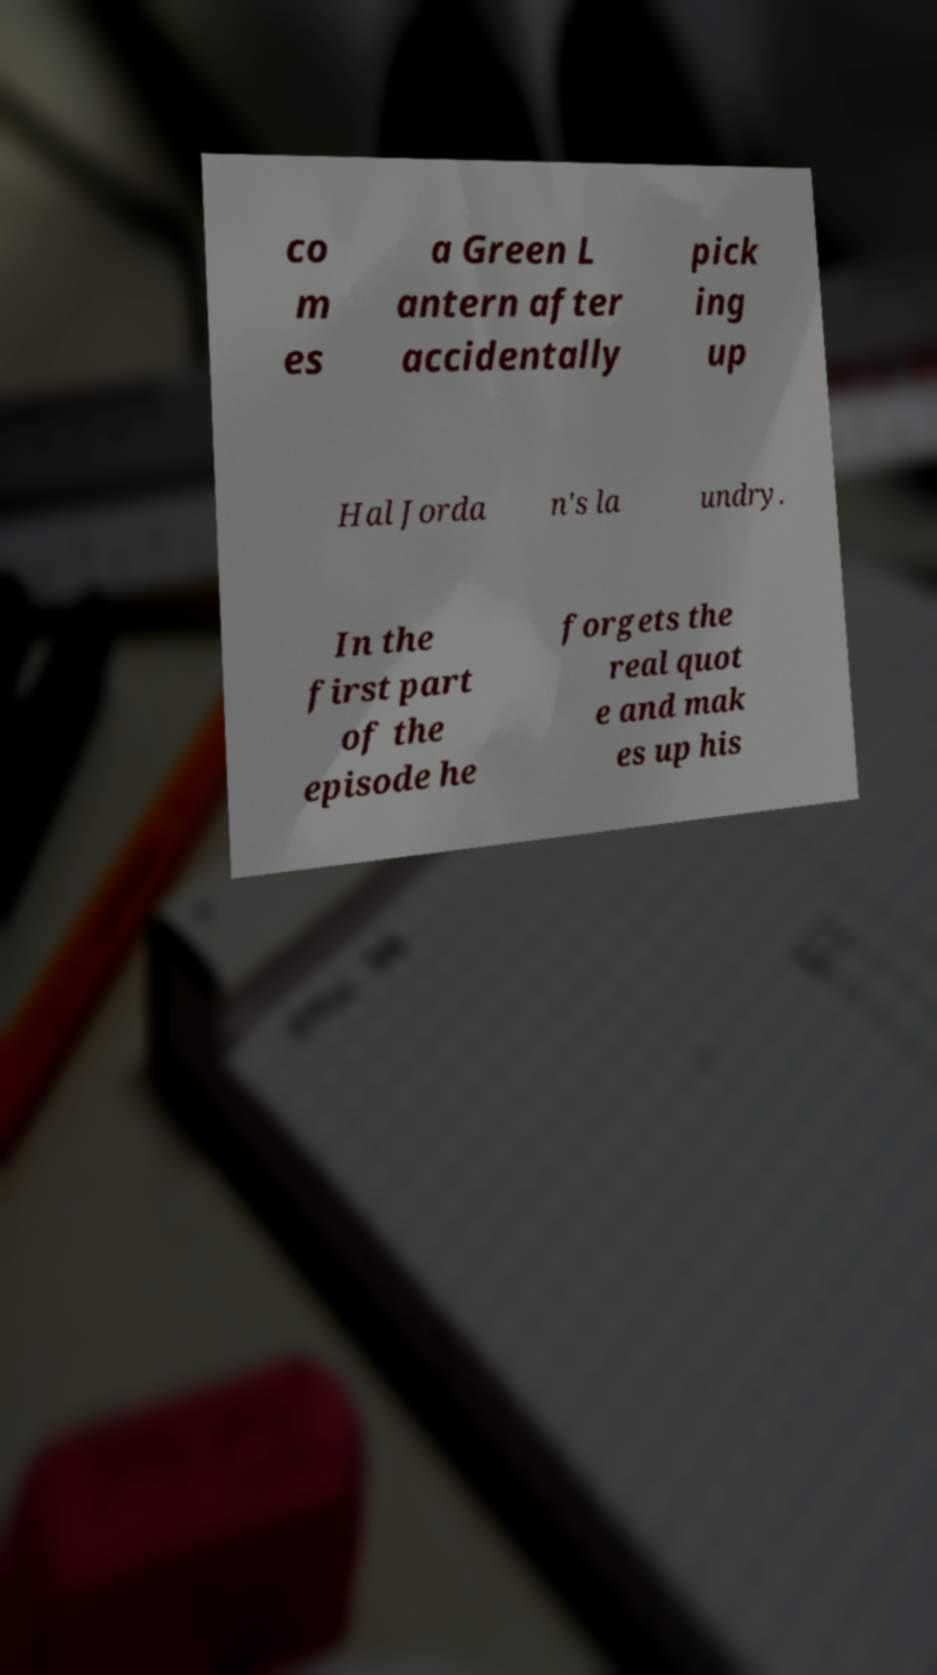What messages or text are displayed in this image? I need them in a readable, typed format. co m es a Green L antern after accidentally pick ing up Hal Jorda n's la undry. In the first part of the episode he forgets the real quot e and mak es up his 